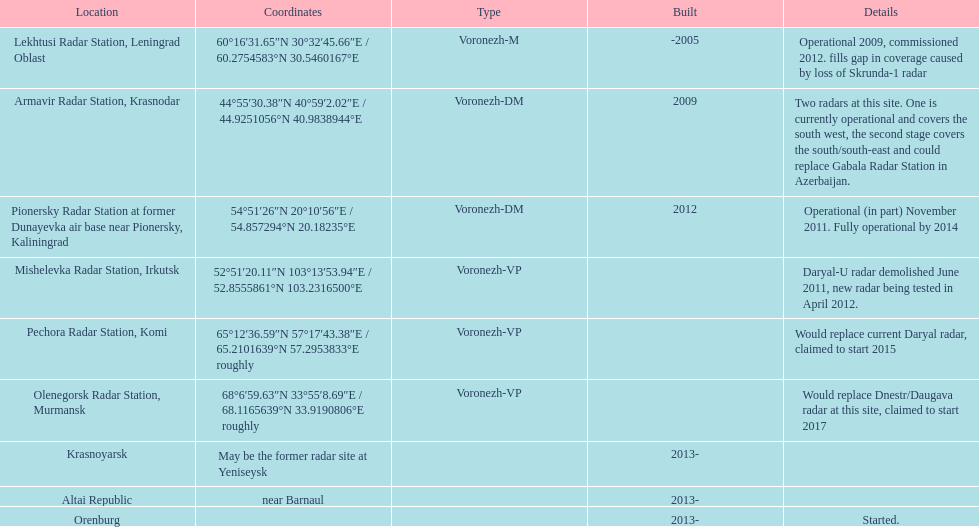What was the duration for the pionersky radar station to transition from partially operational to completely operational? 3 years. 